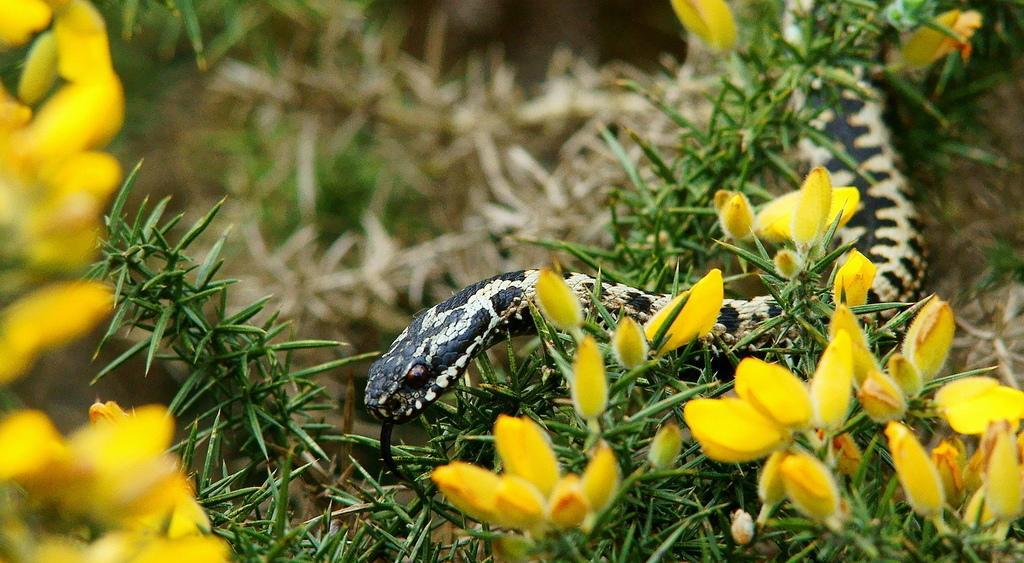Could you give a brief overview of what you see in this image? In this image there are flower plants at the bottom. There is a snake in between the plants. 